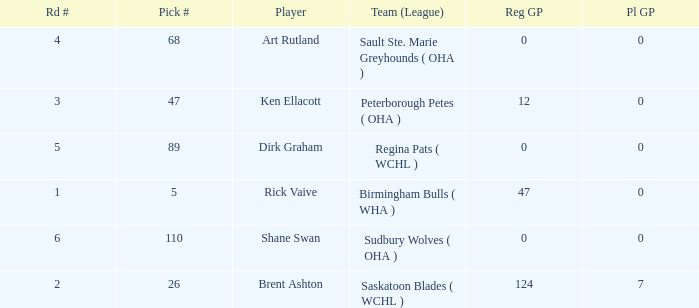How many reg GP for rick vaive in round 1? None. Give me the full table as a dictionary. {'header': ['Rd #', 'Pick #', 'Player', 'Team (League)', 'Reg GP', 'Pl GP'], 'rows': [['4', '68', 'Art Rutland', 'Sault Ste. Marie Greyhounds ( OHA )', '0', '0'], ['3', '47', 'Ken Ellacott', 'Peterborough Petes ( OHA )', '12', '0'], ['5', '89', 'Dirk Graham', 'Regina Pats ( WCHL )', '0', '0'], ['1', '5', 'Rick Vaive', 'Birmingham Bulls ( WHA )', '47', '0'], ['6', '110', 'Shane Swan', 'Sudbury Wolves ( OHA )', '0', '0'], ['2', '26', 'Brent Ashton', 'Saskatoon Blades ( WCHL )', '124', '7']]} 